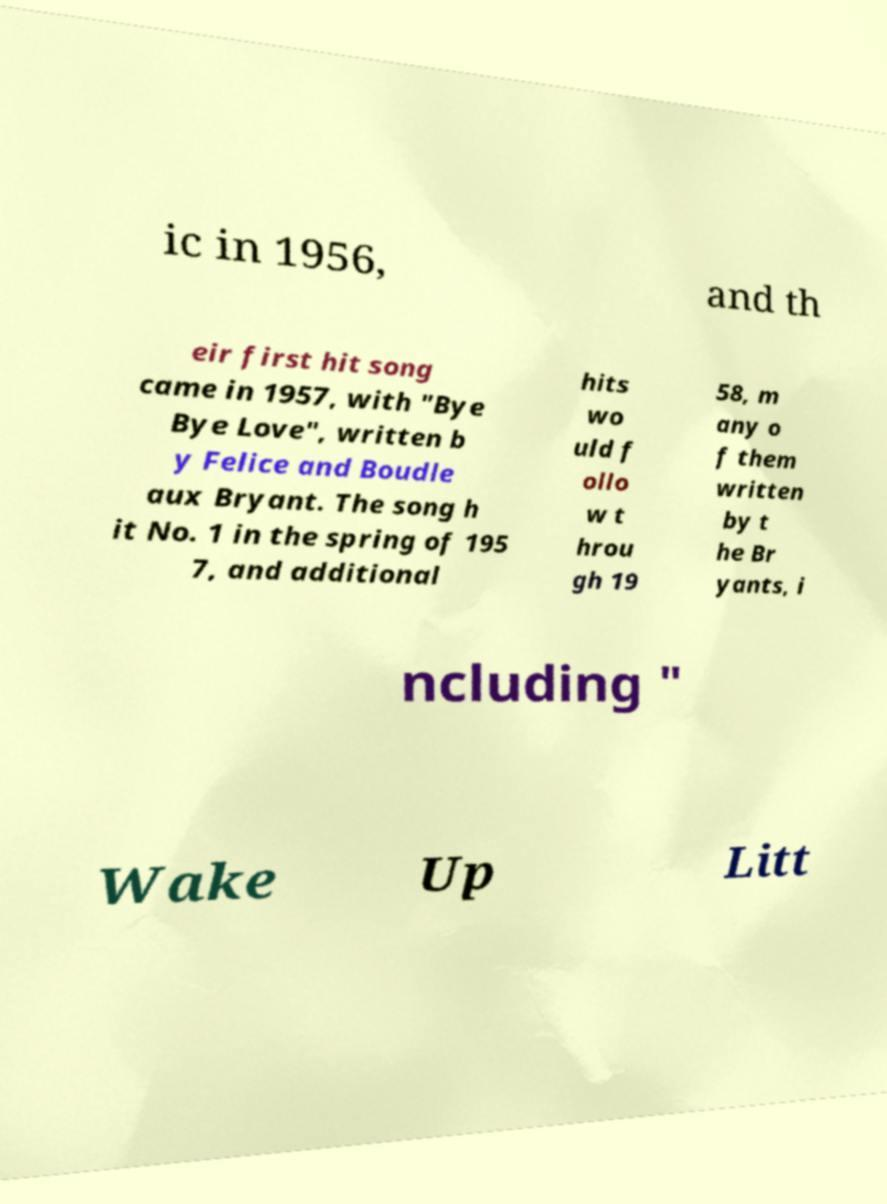Could you extract and type out the text from this image? ic in 1956, and th eir first hit song came in 1957, with "Bye Bye Love", written b y Felice and Boudle aux Bryant. The song h it No. 1 in the spring of 195 7, and additional hits wo uld f ollo w t hrou gh 19 58, m any o f them written by t he Br yants, i ncluding " Wake Up Litt 